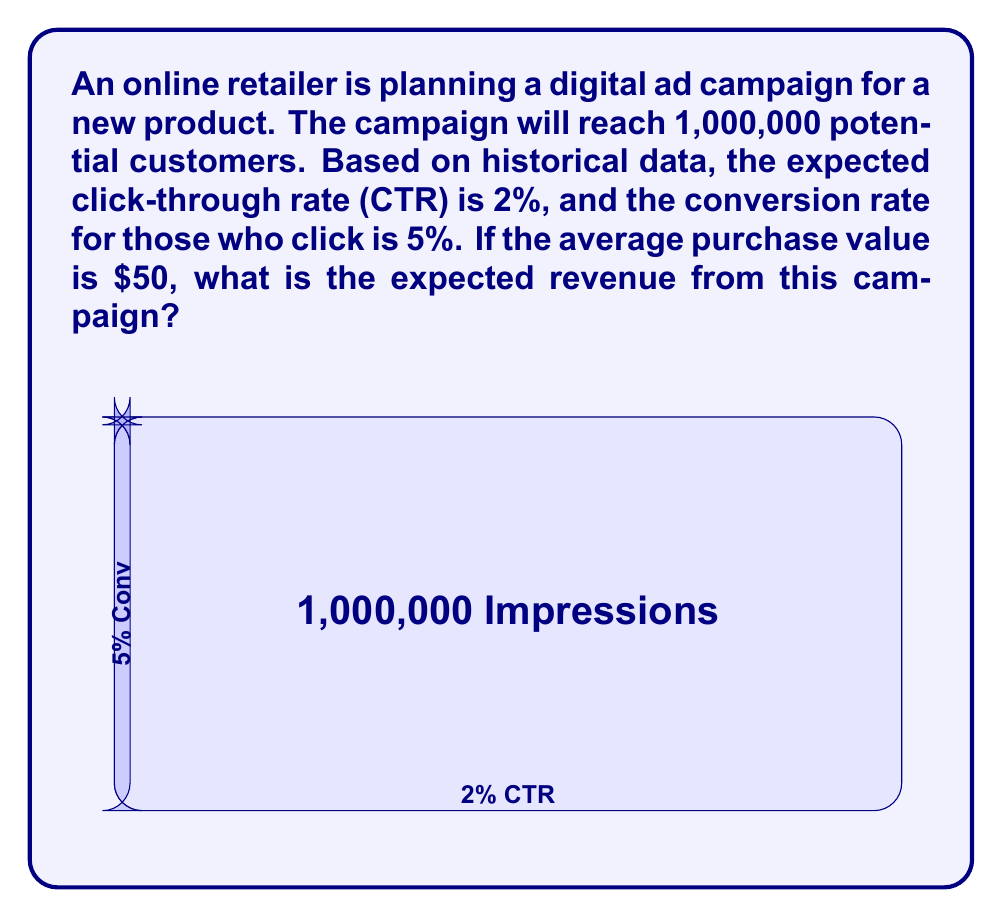Can you answer this question? Let's break this down step-by-step:

1) First, we need to calculate the number of clicks:
   $$ \text{Clicks} = \text{Impressions} \times \text{CTR} $$
   $$ \text{Clicks} = 1,000,000 \times 2\% = 20,000 $$

2) Next, we calculate the number of conversions:
   $$ \text{Conversions} = \text{Clicks} \times \text{Conversion Rate} $$
   $$ \text{Conversions} = 20,000 \times 5\% = 1,000 $$

3) Now, we can calculate the expected revenue:
   $$ \text{Expected Revenue} = \text{Conversions} \times \text{Average Purchase Value} $$
   $$ \text{Expected Revenue} = 1,000 \times \$50 = \$50,000 $$

Therefore, the expected revenue from this campaign is $50,000.
Answer: $50,000 